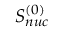Convert formula to latex. <formula><loc_0><loc_0><loc_500><loc_500>S _ { n u c } ^ { ( 0 ) }</formula> 